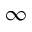Convert formula to latex. <formula><loc_0><loc_0><loc_500><loc_500>\infty</formula> 